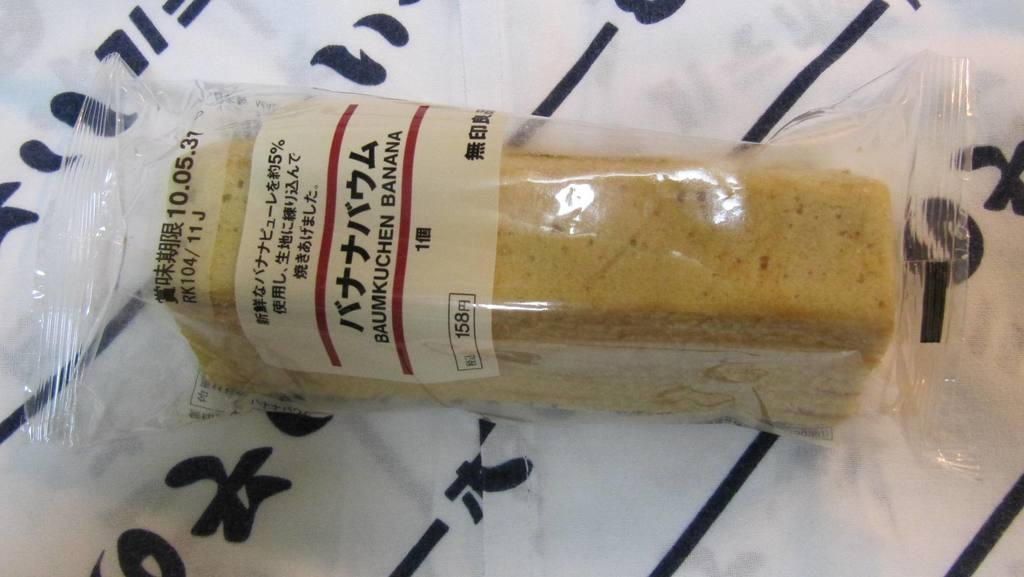<image>
Relay a brief, clear account of the picture shown. a desert wrapped in plastic that reads : baumkuchen banana 